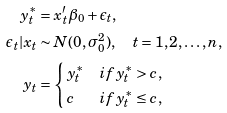Convert formula to latex. <formula><loc_0><loc_0><loc_500><loc_500>y ^ { * } _ { t } & = x ^ { \prime } _ { t } \beta _ { 0 } + \epsilon _ { t } , \\ \epsilon _ { t } | x _ { t } & \sim N ( 0 , \sigma ^ { 2 } _ { 0 } ) , \quad t = 1 , 2 , \dots , n , \\ y _ { t } & = \begin{cases} \, y ^ { * } _ { t } & i f y ^ { * } _ { t } > c , \\ \, c & i f y ^ { * } _ { t } \leq c , \end{cases}</formula> 